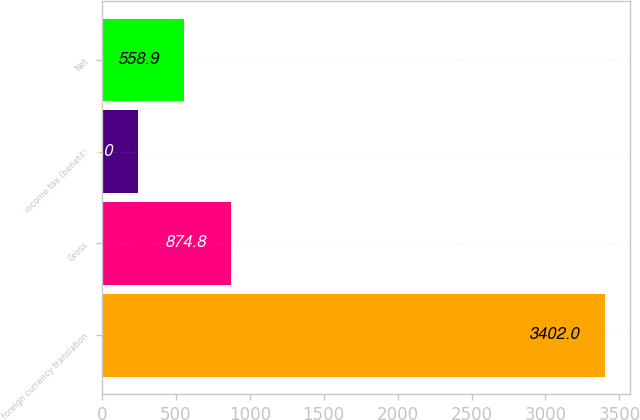<chart> <loc_0><loc_0><loc_500><loc_500><bar_chart><fcel>foreign currency translation<fcel>Gross<fcel>income tax (benefit)<fcel>Net<nl><fcel>3402<fcel>874.8<fcel>243<fcel>558.9<nl></chart> 